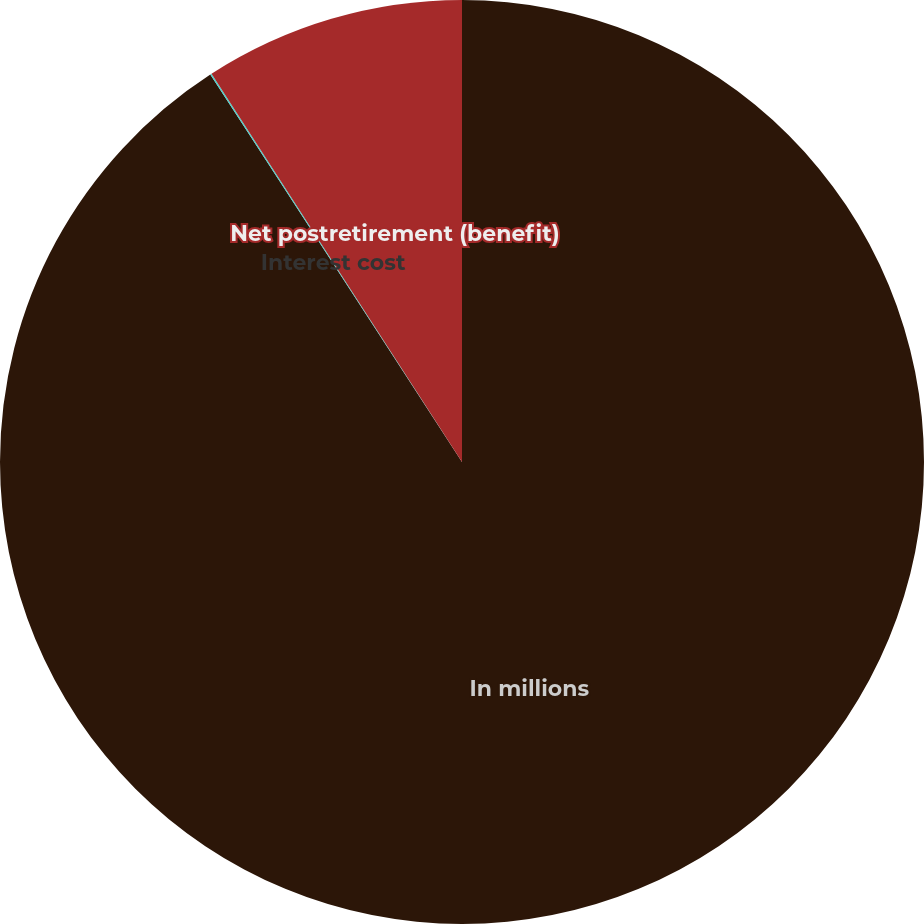Convert chart to OTSL. <chart><loc_0><loc_0><loc_500><loc_500><pie_chart><fcel>In millions<fcel>Interest cost<fcel>Net postretirement (benefit)<nl><fcel>90.83%<fcel>0.05%<fcel>9.12%<nl></chart> 